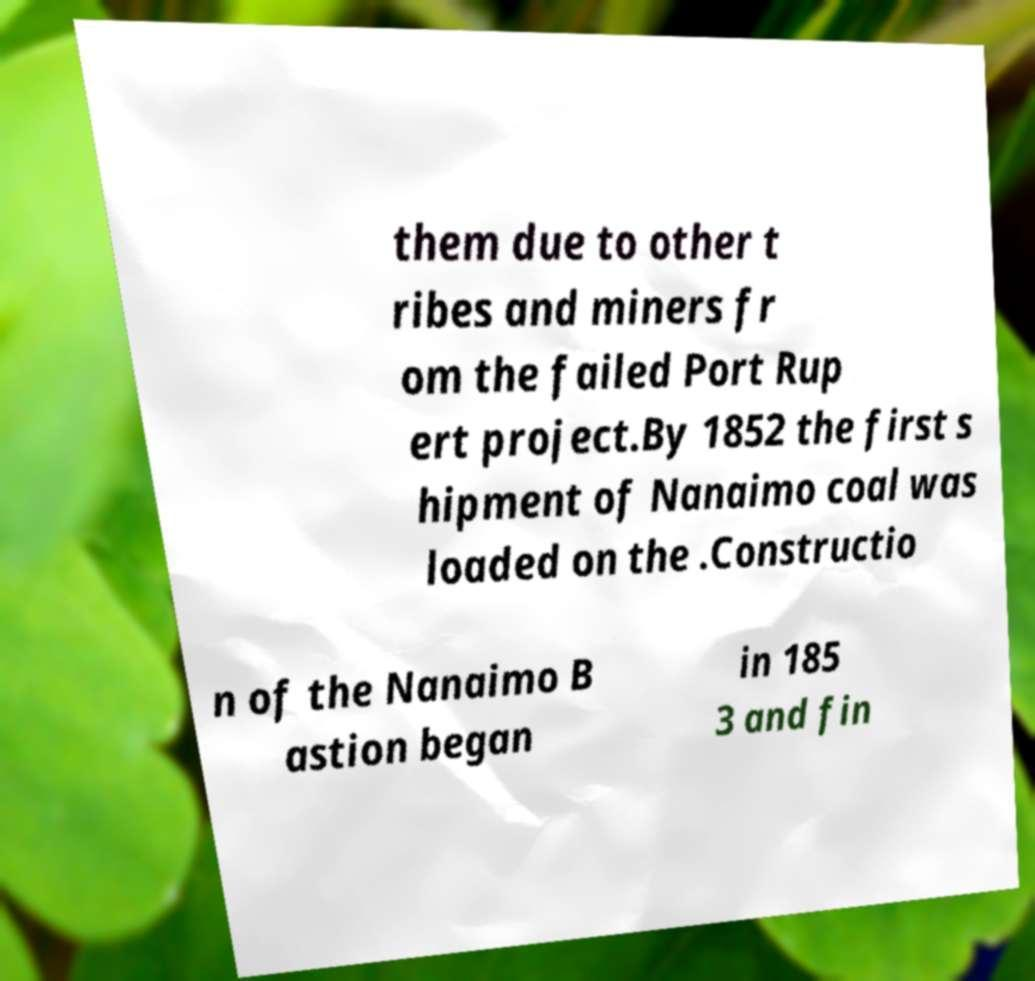Can you accurately transcribe the text from the provided image for me? them due to other t ribes and miners fr om the failed Port Rup ert project.By 1852 the first s hipment of Nanaimo coal was loaded on the .Constructio n of the Nanaimo B astion began in 185 3 and fin 